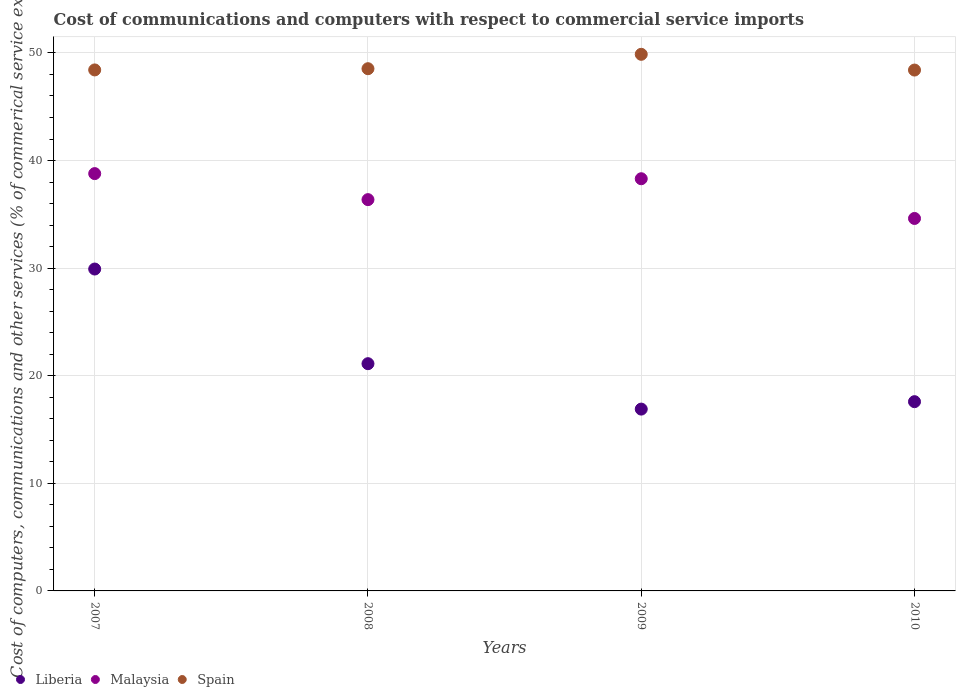How many different coloured dotlines are there?
Keep it short and to the point. 3. What is the cost of communications and computers in Liberia in 2007?
Your answer should be very brief. 29.92. Across all years, what is the maximum cost of communications and computers in Malaysia?
Your answer should be compact. 38.79. Across all years, what is the minimum cost of communications and computers in Liberia?
Your response must be concise. 16.9. In which year was the cost of communications and computers in Malaysia maximum?
Make the answer very short. 2007. What is the total cost of communications and computers in Spain in the graph?
Provide a succinct answer. 195.24. What is the difference between the cost of communications and computers in Malaysia in 2007 and that in 2010?
Your response must be concise. 4.17. What is the difference between the cost of communications and computers in Spain in 2007 and the cost of communications and computers in Malaysia in 2008?
Keep it short and to the point. 12.06. What is the average cost of communications and computers in Spain per year?
Offer a very short reply. 48.81. In the year 2010, what is the difference between the cost of communications and computers in Malaysia and cost of communications and computers in Spain?
Your answer should be compact. -13.79. What is the ratio of the cost of communications and computers in Malaysia in 2009 to that in 2010?
Provide a short and direct response. 1.11. Is the cost of communications and computers in Malaysia in 2007 less than that in 2010?
Provide a short and direct response. No. Is the difference between the cost of communications and computers in Malaysia in 2007 and 2010 greater than the difference between the cost of communications and computers in Spain in 2007 and 2010?
Make the answer very short. Yes. What is the difference between the highest and the second highest cost of communications and computers in Malaysia?
Your response must be concise. 0.48. What is the difference between the highest and the lowest cost of communications and computers in Spain?
Offer a very short reply. 1.46. In how many years, is the cost of communications and computers in Liberia greater than the average cost of communications and computers in Liberia taken over all years?
Ensure brevity in your answer.  1. Is it the case that in every year, the sum of the cost of communications and computers in Spain and cost of communications and computers in Liberia  is greater than the cost of communications and computers in Malaysia?
Provide a succinct answer. Yes. Is the cost of communications and computers in Liberia strictly greater than the cost of communications and computers in Spain over the years?
Your response must be concise. No. Is the cost of communications and computers in Spain strictly less than the cost of communications and computers in Malaysia over the years?
Keep it short and to the point. No. How many years are there in the graph?
Offer a terse response. 4. Does the graph contain grids?
Offer a very short reply. Yes. Where does the legend appear in the graph?
Provide a short and direct response. Bottom left. How many legend labels are there?
Provide a succinct answer. 3. How are the legend labels stacked?
Ensure brevity in your answer.  Horizontal. What is the title of the graph?
Your response must be concise. Cost of communications and computers with respect to commercial service imports. What is the label or title of the Y-axis?
Provide a short and direct response. Cost of computers, communications and other services (% of commerical service exports). What is the Cost of computers, communications and other services (% of commerical service exports) in Liberia in 2007?
Provide a succinct answer. 29.92. What is the Cost of computers, communications and other services (% of commerical service exports) of Malaysia in 2007?
Keep it short and to the point. 38.79. What is the Cost of computers, communications and other services (% of commerical service exports) in Spain in 2007?
Keep it short and to the point. 48.42. What is the Cost of computers, communications and other services (% of commerical service exports) in Liberia in 2008?
Make the answer very short. 21.12. What is the Cost of computers, communications and other services (% of commerical service exports) in Malaysia in 2008?
Make the answer very short. 36.37. What is the Cost of computers, communications and other services (% of commerical service exports) in Spain in 2008?
Keep it short and to the point. 48.54. What is the Cost of computers, communications and other services (% of commerical service exports) in Liberia in 2009?
Provide a short and direct response. 16.9. What is the Cost of computers, communications and other services (% of commerical service exports) in Malaysia in 2009?
Your answer should be compact. 38.31. What is the Cost of computers, communications and other services (% of commerical service exports) of Spain in 2009?
Your answer should be compact. 49.87. What is the Cost of computers, communications and other services (% of commerical service exports) of Liberia in 2010?
Your response must be concise. 17.59. What is the Cost of computers, communications and other services (% of commerical service exports) of Malaysia in 2010?
Your answer should be very brief. 34.62. What is the Cost of computers, communications and other services (% of commerical service exports) of Spain in 2010?
Make the answer very short. 48.41. Across all years, what is the maximum Cost of computers, communications and other services (% of commerical service exports) in Liberia?
Make the answer very short. 29.92. Across all years, what is the maximum Cost of computers, communications and other services (% of commerical service exports) in Malaysia?
Provide a succinct answer. 38.79. Across all years, what is the maximum Cost of computers, communications and other services (% of commerical service exports) in Spain?
Keep it short and to the point. 49.87. Across all years, what is the minimum Cost of computers, communications and other services (% of commerical service exports) in Liberia?
Offer a terse response. 16.9. Across all years, what is the minimum Cost of computers, communications and other services (% of commerical service exports) in Malaysia?
Your answer should be very brief. 34.62. Across all years, what is the minimum Cost of computers, communications and other services (% of commerical service exports) of Spain?
Your answer should be compact. 48.41. What is the total Cost of computers, communications and other services (% of commerical service exports) in Liberia in the graph?
Your answer should be compact. 85.52. What is the total Cost of computers, communications and other services (% of commerical service exports) in Malaysia in the graph?
Your answer should be very brief. 148.08. What is the total Cost of computers, communications and other services (% of commerical service exports) of Spain in the graph?
Keep it short and to the point. 195.24. What is the difference between the Cost of computers, communications and other services (% of commerical service exports) in Liberia in 2007 and that in 2008?
Make the answer very short. 8.8. What is the difference between the Cost of computers, communications and other services (% of commerical service exports) of Malaysia in 2007 and that in 2008?
Ensure brevity in your answer.  2.42. What is the difference between the Cost of computers, communications and other services (% of commerical service exports) in Spain in 2007 and that in 2008?
Make the answer very short. -0.11. What is the difference between the Cost of computers, communications and other services (% of commerical service exports) in Liberia in 2007 and that in 2009?
Your response must be concise. 13.02. What is the difference between the Cost of computers, communications and other services (% of commerical service exports) in Malaysia in 2007 and that in 2009?
Offer a terse response. 0.48. What is the difference between the Cost of computers, communications and other services (% of commerical service exports) of Spain in 2007 and that in 2009?
Provide a short and direct response. -1.45. What is the difference between the Cost of computers, communications and other services (% of commerical service exports) in Liberia in 2007 and that in 2010?
Offer a very short reply. 12.33. What is the difference between the Cost of computers, communications and other services (% of commerical service exports) of Malaysia in 2007 and that in 2010?
Offer a terse response. 4.17. What is the difference between the Cost of computers, communications and other services (% of commerical service exports) of Spain in 2007 and that in 2010?
Your answer should be very brief. 0.01. What is the difference between the Cost of computers, communications and other services (% of commerical service exports) in Liberia in 2008 and that in 2009?
Your answer should be very brief. 4.22. What is the difference between the Cost of computers, communications and other services (% of commerical service exports) in Malaysia in 2008 and that in 2009?
Ensure brevity in your answer.  -1.94. What is the difference between the Cost of computers, communications and other services (% of commerical service exports) in Spain in 2008 and that in 2009?
Your answer should be very brief. -1.34. What is the difference between the Cost of computers, communications and other services (% of commerical service exports) of Liberia in 2008 and that in 2010?
Make the answer very short. 3.53. What is the difference between the Cost of computers, communications and other services (% of commerical service exports) in Malaysia in 2008 and that in 2010?
Make the answer very short. 1.75. What is the difference between the Cost of computers, communications and other services (% of commerical service exports) in Spain in 2008 and that in 2010?
Give a very brief answer. 0.13. What is the difference between the Cost of computers, communications and other services (% of commerical service exports) of Liberia in 2009 and that in 2010?
Give a very brief answer. -0.69. What is the difference between the Cost of computers, communications and other services (% of commerical service exports) of Malaysia in 2009 and that in 2010?
Your answer should be compact. 3.69. What is the difference between the Cost of computers, communications and other services (% of commerical service exports) of Spain in 2009 and that in 2010?
Ensure brevity in your answer.  1.46. What is the difference between the Cost of computers, communications and other services (% of commerical service exports) in Liberia in 2007 and the Cost of computers, communications and other services (% of commerical service exports) in Malaysia in 2008?
Offer a terse response. -6.45. What is the difference between the Cost of computers, communications and other services (% of commerical service exports) in Liberia in 2007 and the Cost of computers, communications and other services (% of commerical service exports) in Spain in 2008?
Keep it short and to the point. -18.62. What is the difference between the Cost of computers, communications and other services (% of commerical service exports) of Malaysia in 2007 and the Cost of computers, communications and other services (% of commerical service exports) of Spain in 2008?
Offer a very short reply. -9.75. What is the difference between the Cost of computers, communications and other services (% of commerical service exports) in Liberia in 2007 and the Cost of computers, communications and other services (% of commerical service exports) in Malaysia in 2009?
Provide a succinct answer. -8.39. What is the difference between the Cost of computers, communications and other services (% of commerical service exports) in Liberia in 2007 and the Cost of computers, communications and other services (% of commerical service exports) in Spain in 2009?
Ensure brevity in your answer.  -19.96. What is the difference between the Cost of computers, communications and other services (% of commerical service exports) in Malaysia in 2007 and the Cost of computers, communications and other services (% of commerical service exports) in Spain in 2009?
Keep it short and to the point. -11.09. What is the difference between the Cost of computers, communications and other services (% of commerical service exports) of Liberia in 2007 and the Cost of computers, communications and other services (% of commerical service exports) of Malaysia in 2010?
Offer a very short reply. -4.7. What is the difference between the Cost of computers, communications and other services (% of commerical service exports) in Liberia in 2007 and the Cost of computers, communications and other services (% of commerical service exports) in Spain in 2010?
Keep it short and to the point. -18.49. What is the difference between the Cost of computers, communications and other services (% of commerical service exports) of Malaysia in 2007 and the Cost of computers, communications and other services (% of commerical service exports) of Spain in 2010?
Your answer should be compact. -9.62. What is the difference between the Cost of computers, communications and other services (% of commerical service exports) in Liberia in 2008 and the Cost of computers, communications and other services (% of commerical service exports) in Malaysia in 2009?
Offer a terse response. -17.19. What is the difference between the Cost of computers, communications and other services (% of commerical service exports) of Liberia in 2008 and the Cost of computers, communications and other services (% of commerical service exports) of Spain in 2009?
Make the answer very short. -28.75. What is the difference between the Cost of computers, communications and other services (% of commerical service exports) of Malaysia in 2008 and the Cost of computers, communications and other services (% of commerical service exports) of Spain in 2009?
Keep it short and to the point. -13.51. What is the difference between the Cost of computers, communications and other services (% of commerical service exports) in Liberia in 2008 and the Cost of computers, communications and other services (% of commerical service exports) in Malaysia in 2010?
Make the answer very short. -13.5. What is the difference between the Cost of computers, communications and other services (% of commerical service exports) of Liberia in 2008 and the Cost of computers, communications and other services (% of commerical service exports) of Spain in 2010?
Ensure brevity in your answer.  -27.29. What is the difference between the Cost of computers, communications and other services (% of commerical service exports) of Malaysia in 2008 and the Cost of computers, communications and other services (% of commerical service exports) of Spain in 2010?
Make the answer very short. -12.04. What is the difference between the Cost of computers, communications and other services (% of commerical service exports) of Liberia in 2009 and the Cost of computers, communications and other services (% of commerical service exports) of Malaysia in 2010?
Your answer should be very brief. -17.72. What is the difference between the Cost of computers, communications and other services (% of commerical service exports) in Liberia in 2009 and the Cost of computers, communications and other services (% of commerical service exports) in Spain in 2010?
Your answer should be very brief. -31.51. What is the difference between the Cost of computers, communications and other services (% of commerical service exports) in Malaysia in 2009 and the Cost of computers, communications and other services (% of commerical service exports) in Spain in 2010?
Your answer should be very brief. -10.1. What is the average Cost of computers, communications and other services (% of commerical service exports) of Liberia per year?
Provide a short and direct response. 21.38. What is the average Cost of computers, communications and other services (% of commerical service exports) of Malaysia per year?
Make the answer very short. 37.02. What is the average Cost of computers, communications and other services (% of commerical service exports) in Spain per year?
Provide a succinct answer. 48.81. In the year 2007, what is the difference between the Cost of computers, communications and other services (% of commerical service exports) of Liberia and Cost of computers, communications and other services (% of commerical service exports) of Malaysia?
Make the answer very short. -8.87. In the year 2007, what is the difference between the Cost of computers, communications and other services (% of commerical service exports) of Liberia and Cost of computers, communications and other services (% of commerical service exports) of Spain?
Ensure brevity in your answer.  -18.51. In the year 2007, what is the difference between the Cost of computers, communications and other services (% of commerical service exports) in Malaysia and Cost of computers, communications and other services (% of commerical service exports) in Spain?
Give a very brief answer. -9.64. In the year 2008, what is the difference between the Cost of computers, communications and other services (% of commerical service exports) of Liberia and Cost of computers, communications and other services (% of commerical service exports) of Malaysia?
Your response must be concise. -15.25. In the year 2008, what is the difference between the Cost of computers, communications and other services (% of commerical service exports) in Liberia and Cost of computers, communications and other services (% of commerical service exports) in Spain?
Give a very brief answer. -27.42. In the year 2008, what is the difference between the Cost of computers, communications and other services (% of commerical service exports) in Malaysia and Cost of computers, communications and other services (% of commerical service exports) in Spain?
Offer a very short reply. -12.17. In the year 2009, what is the difference between the Cost of computers, communications and other services (% of commerical service exports) of Liberia and Cost of computers, communications and other services (% of commerical service exports) of Malaysia?
Provide a succinct answer. -21.41. In the year 2009, what is the difference between the Cost of computers, communications and other services (% of commerical service exports) of Liberia and Cost of computers, communications and other services (% of commerical service exports) of Spain?
Provide a succinct answer. -32.97. In the year 2009, what is the difference between the Cost of computers, communications and other services (% of commerical service exports) in Malaysia and Cost of computers, communications and other services (% of commerical service exports) in Spain?
Your response must be concise. -11.56. In the year 2010, what is the difference between the Cost of computers, communications and other services (% of commerical service exports) of Liberia and Cost of computers, communications and other services (% of commerical service exports) of Malaysia?
Offer a very short reply. -17.03. In the year 2010, what is the difference between the Cost of computers, communications and other services (% of commerical service exports) of Liberia and Cost of computers, communications and other services (% of commerical service exports) of Spain?
Keep it short and to the point. -30.82. In the year 2010, what is the difference between the Cost of computers, communications and other services (% of commerical service exports) in Malaysia and Cost of computers, communications and other services (% of commerical service exports) in Spain?
Ensure brevity in your answer.  -13.79. What is the ratio of the Cost of computers, communications and other services (% of commerical service exports) of Liberia in 2007 to that in 2008?
Your response must be concise. 1.42. What is the ratio of the Cost of computers, communications and other services (% of commerical service exports) in Malaysia in 2007 to that in 2008?
Ensure brevity in your answer.  1.07. What is the ratio of the Cost of computers, communications and other services (% of commerical service exports) in Liberia in 2007 to that in 2009?
Make the answer very short. 1.77. What is the ratio of the Cost of computers, communications and other services (% of commerical service exports) of Malaysia in 2007 to that in 2009?
Give a very brief answer. 1.01. What is the ratio of the Cost of computers, communications and other services (% of commerical service exports) of Spain in 2007 to that in 2009?
Your answer should be very brief. 0.97. What is the ratio of the Cost of computers, communications and other services (% of commerical service exports) in Liberia in 2007 to that in 2010?
Keep it short and to the point. 1.7. What is the ratio of the Cost of computers, communications and other services (% of commerical service exports) in Malaysia in 2007 to that in 2010?
Your answer should be compact. 1.12. What is the ratio of the Cost of computers, communications and other services (% of commerical service exports) in Liberia in 2008 to that in 2009?
Your response must be concise. 1.25. What is the ratio of the Cost of computers, communications and other services (% of commerical service exports) of Malaysia in 2008 to that in 2009?
Provide a short and direct response. 0.95. What is the ratio of the Cost of computers, communications and other services (% of commerical service exports) in Spain in 2008 to that in 2009?
Your response must be concise. 0.97. What is the ratio of the Cost of computers, communications and other services (% of commerical service exports) of Liberia in 2008 to that in 2010?
Offer a terse response. 1.2. What is the ratio of the Cost of computers, communications and other services (% of commerical service exports) in Malaysia in 2008 to that in 2010?
Your answer should be compact. 1.05. What is the ratio of the Cost of computers, communications and other services (% of commerical service exports) in Liberia in 2009 to that in 2010?
Offer a very short reply. 0.96. What is the ratio of the Cost of computers, communications and other services (% of commerical service exports) of Malaysia in 2009 to that in 2010?
Offer a very short reply. 1.11. What is the ratio of the Cost of computers, communications and other services (% of commerical service exports) in Spain in 2009 to that in 2010?
Your answer should be compact. 1.03. What is the difference between the highest and the second highest Cost of computers, communications and other services (% of commerical service exports) in Liberia?
Your answer should be compact. 8.8. What is the difference between the highest and the second highest Cost of computers, communications and other services (% of commerical service exports) of Malaysia?
Offer a very short reply. 0.48. What is the difference between the highest and the second highest Cost of computers, communications and other services (% of commerical service exports) of Spain?
Make the answer very short. 1.34. What is the difference between the highest and the lowest Cost of computers, communications and other services (% of commerical service exports) of Liberia?
Offer a very short reply. 13.02. What is the difference between the highest and the lowest Cost of computers, communications and other services (% of commerical service exports) in Malaysia?
Your answer should be very brief. 4.17. What is the difference between the highest and the lowest Cost of computers, communications and other services (% of commerical service exports) in Spain?
Provide a succinct answer. 1.46. 